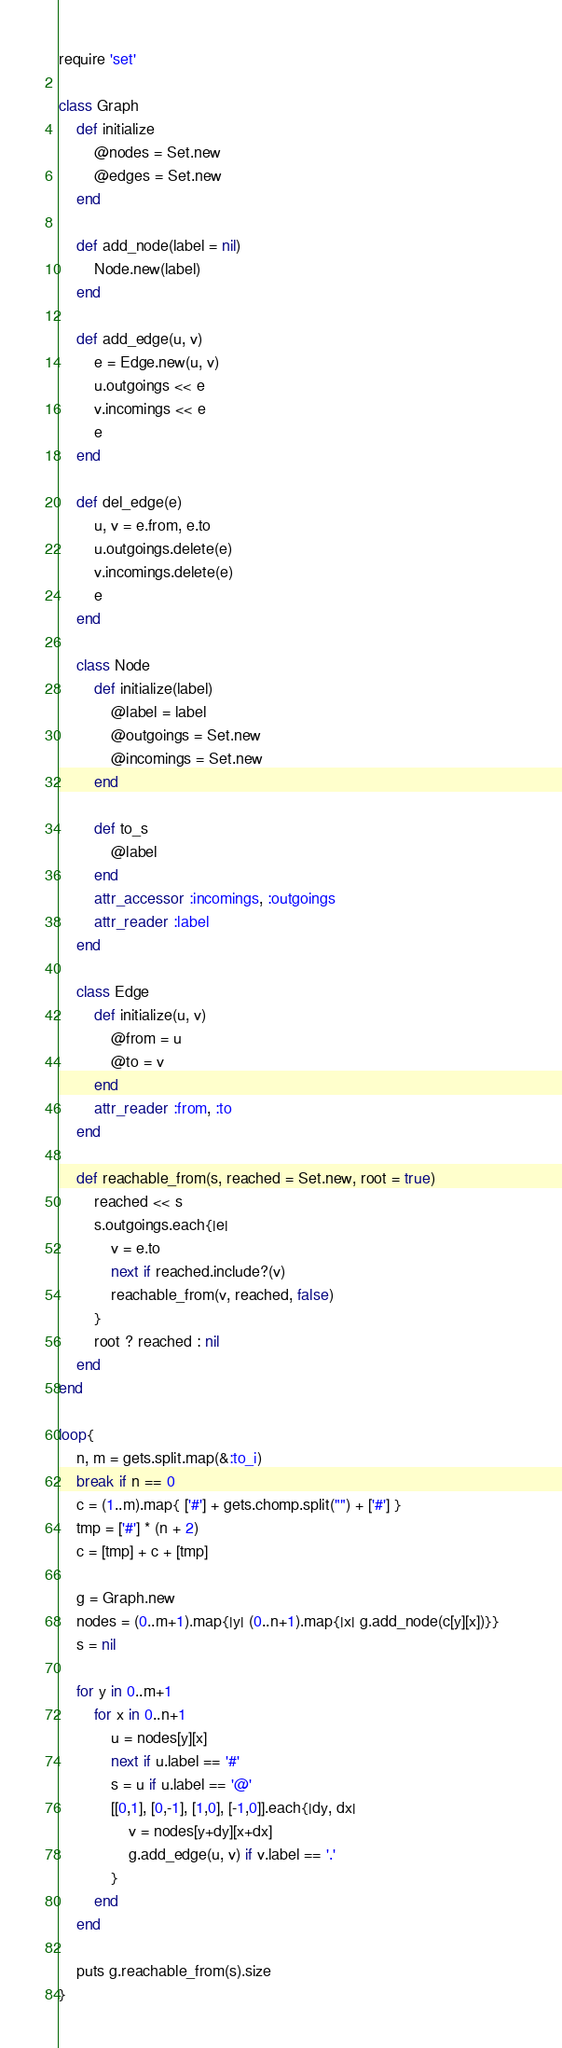Convert code to text. <code><loc_0><loc_0><loc_500><loc_500><_Ruby_>require 'set'

class Graph
	def initialize
		@nodes = Set.new
		@edges = Set.new
	end

	def add_node(label = nil)
		Node.new(label)
	end

	def add_edge(u, v)
		e = Edge.new(u, v)
		u.outgoings << e
		v.incomings << e
		e
	end
	
	def del_edge(e)
		u, v = e.from, e.to
		u.outgoings.delete(e)
		v.incomings.delete(e)
		e
	end

	class Node
		def initialize(label)
			@label = label
			@outgoings = Set.new
			@incomings = Set.new
		end
		
		def to_s
			@label
		end
		attr_accessor :incomings, :outgoings
		attr_reader :label
	end

	class Edge
		def initialize(u, v)
			@from = u	
			@to = v
		end
		attr_reader :from, :to
	end

	def reachable_from(s, reached = Set.new, root = true)
		reached << s	
		s.outgoings.each{|e|
			v = e.to
			next if reached.include?(v)
			reachable_from(v, reached, false) 
		}
		root ? reached : nil
	end
end

loop{
	n, m = gets.split.map(&:to_i)
	break if n == 0
	c = (1..m).map{ ['#'] + gets.chomp.split("") + ['#'] }
	tmp = ['#'] * (n + 2)
	c = [tmp] + c + [tmp]

	g = Graph.new
	nodes = (0..m+1).map{|y| (0..n+1).map{|x| g.add_node(c[y][x])}}	
	s = nil

	for y in 0..m+1
		for x in 0..n+1
			u = nodes[y][x]
			next if u.label == '#'
			s = u if u.label == '@'
			[[0,1], [0,-1], [1,0], [-1,0]].each{|dy, dx|
				v = nodes[y+dy][x+dx]
				g.add_edge(u, v) if v.label == '.'	
			}
		end
	end
	
	puts g.reachable_from(s).size
}</code> 